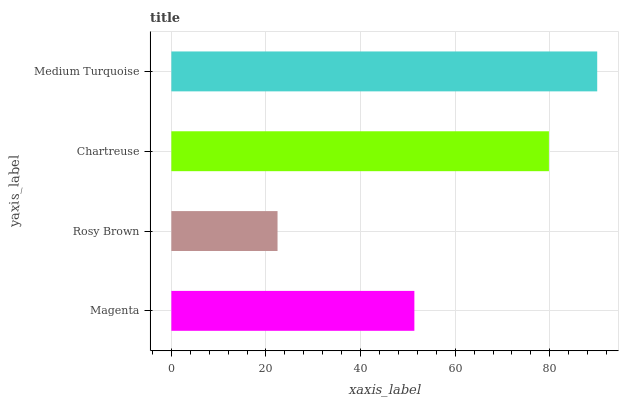Is Rosy Brown the minimum?
Answer yes or no. Yes. Is Medium Turquoise the maximum?
Answer yes or no. Yes. Is Chartreuse the minimum?
Answer yes or no. No. Is Chartreuse the maximum?
Answer yes or no. No. Is Chartreuse greater than Rosy Brown?
Answer yes or no. Yes. Is Rosy Brown less than Chartreuse?
Answer yes or no. Yes. Is Rosy Brown greater than Chartreuse?
Answer yes or no. No. Is Chartreuse less than Rosy Brown?
Answer yes or no. No. Is Chartreuse the high median?
Answer yes or no. Yes. Is Magenta the low median?
Answer yes or no. Yes. Is Magenta the high median?
Answer yes or no. No. Is Medium Turquoise the low median?
Answer yes or no. No. 